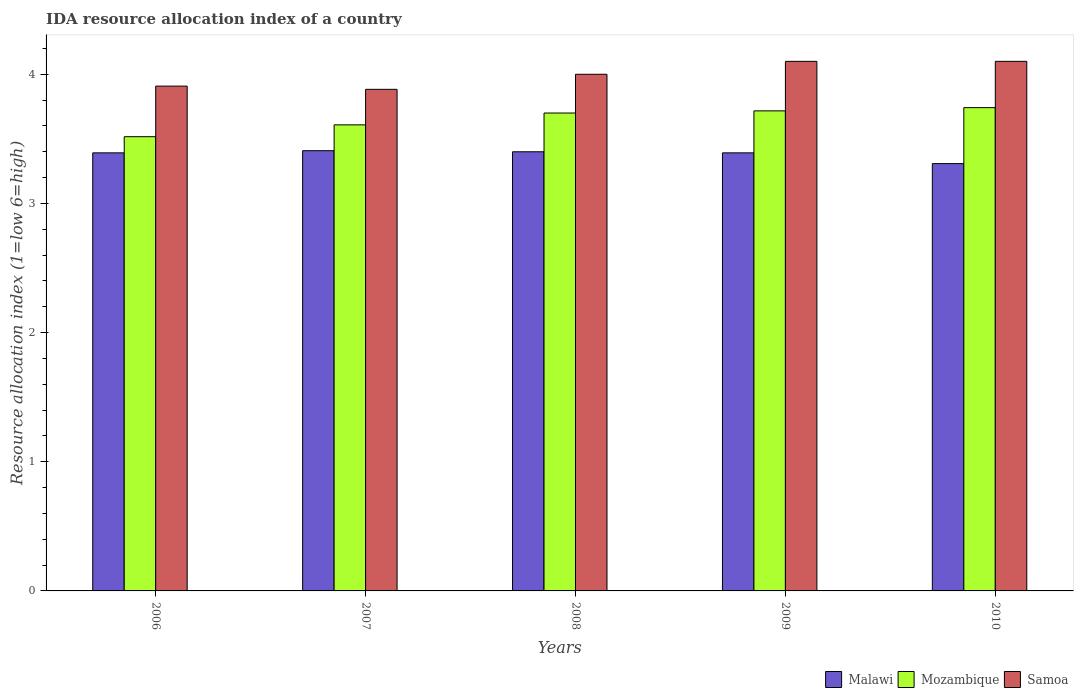How many different coloured bars are there?
Ensure brevity in your answer.  3. Are the number of bars per tick equal to the number of legend labels?
Provide a short and direct response. Yes. How many bars are there on the 1st tick from the right?
Ensure brevity in your answer.  3. In how many cases, is the number of bars for a given year not equal to the number of legend labels?
Offer a terse response. 0. What is the IDA resource allocation index in Samoa in 2006?
Offer a very short reply. 3.91. Across all years, what is the maximum IDA resource allocation index in Mozambique?
Offer a terse response. 3.74. Across all years, what is the minimum IDA resource allocation index in Samoa?
Your answer should be compact. 3.88. In which year was the IDA resource allocation index in Samoa maximum?
Your answer should be very brief. 2009. What is the total IDA resource allocation index in Malawi in the graph?
Provide a short and direct response. 16.9. What is the difference between the IDA resource allocation index in Malawi in 2008 and that in 2010?
Provide a succinct answer. 0.09. What is the difference between the IDA resource allocation index in Samoa in 2007 and the IDA resource allocation index in Mozambique in 2010?
Your response must be concise. 0.14. What is the average IDA resource allocation index in Samoa per year?
Your answer should be compact. 4. In the year 2009, what is the difference between the IDA resource allocation index in Malawi and IDA resource allocation index in Samoa?
Provide a succinct answer. -0.71. In how many years, is the IDA resource allocation index in Malawi greater than 3.8?
Your answer should be compact. 0. What is the ratio of the IDA resource allocation index in Mozambique in 2009 to that in 2010?
Provide a short and direct response. 0.99. Is the difference between the IDA resource allocation index in Malawi in 2007 and 2010 greater than the difference between the IDA resource allocation index in Samoa in 2007 and 2010?
Your answer should be compact. Yes. What is the difference between the highest and the second highest IDA resource allocation index in Malawi?
Your answer should be very brief. 0.01. What is the difference between the highest and the lowest IDA resource allocation index in Malawi?
Your answer should be very brief. 0.1. In how many years, is the IDA resource allocation index in Samoa greater than the average IDA resource allocation index in Samoa taken over all years?
Make the answer very short. 3. Is the sum of the IDA resource allocation index in Malawi in 2006 and 2007 greater than the maximum IDA resource allocation index in Mozambique across all years?
Make the answer very short. Yes. What does the 2nd bar from the left in 2006 represents?
Make the answer very short. Mozambique. What does the 2nd bar from the right in 2010 represents?
Ensure brevity in your answer.  Mozambique. Is it the case that in every year, the sum of the IDA resource allocation index in Samoa and IDA resource allocation index in Mozambique is greater than the IDA resource allocation index in Malawi?
Offer a very short reply. Yes. How many bars are there?
Keep it short and to the point. 15. Are all the bars in the graph horizontal?
Keep it short and to the point. No. What is the difference between two consecutive major ticks on the Y-axis?
Offer a very short reply. 1. What is the title of the graph?
Your response must be concise. IDA resource allocation index of a country. What is the label or title of the X-axis?
Provide a short and direct response. Years. What is the label or title of the Y-axis?
Your response must be concise. Resource allocation index (1=low 6=high). What is the Resource allocation index (1=low 6=high) of Malawi in 2006?
Keep it short and to the point. 3.39. What is the Resource allocation index (1=low 6=high) of Mozambique in 2006?
Offer a terse response. 3.52. What is the Resource allocation index (1=low 6=high) in Samoa in 2006?
Give a very brief answer. 3.91. What is the Resource allocation index (1=low 6=high) of Malawi in 2007?
Offer a terse response. 3.41. What is the Resource allocation index (1=low 6=high) of Mozambique in 2007?
Offer a very short reply. 3.61. What is the Resource allocation index (1=low 6=high) in Samoa in 2007?
Your answer should be very brief. 3.88. What is the Resource allocation index (1=low 6=high) in Samoa in 2008?
Provide a short and direct response. 4. What is the Resource allocation index (1=low 6=high) of Malawi in 2009?
Your answer should be compact. 3.39. What is the Resource allocation index (1=low 6=high) of Mozambique in 2009?
Your answer should be compact. 3.72. What is the Resource allocation index (1=low 6=high) of Malawi in 2010?
Provide a short and direct response. 3.31. What is the Resource allocation index (1=low 6=high) in Mozambique in 2010?
Provide a short and direct response. 3.74. What is the Resource allocation index (1=low 6=high) in Samoa in 2010?
Make the answer very short. 4.1. Across all years, what is the maximum Resource allocation index (1=low 6=high) in Malawi?
Give a very brief answer. 3.41. Across all years, what is the maximum Resource allocation index (1=low 6=high) in Mozambique?
Offer a very short reply. 3.74. Across all years, what is the maximum Resource allocation index (1=low 6=high) in Samoa?
Provide a succinct answer. 4.1. Across all years, what is the minimum Resource allocation index (1=low 6=high) of Malawi?
Your answer should be compact. 3.31. Across all years, what is the minimum Resource allocation index (1=low 6=high) in Mozambique?
Keep it short and to the point. 3.52. Across all years, what is the minimum Resource allocation index (1=low 6=high) in Samoa?
Offer a terse response. 3.88. What is the total Resource allocation index (1=low 6=high) of Malawi in the graph?
Provide a succinct answer. 16.9. What is the total Resource allocation index (1=low 6=high) in Mozambique in the graph?
Offer a terse response. 18.28. What is the total Resource allocation index (1=low 6=high) of Samoa in the graph?
Ensure brevity in your answer.  19.99. What is the difference between the Resource allocation index (1=low 6=high) of Malawi in 2006 and that in 2007?
Keep it short and to the point. -0.02. What is the difference between the Resource allocation index (1=low 6=high) in Mozambique in 2006 and that in 2007?
Provide a short and direct response. -0.09. What is the difference between the Resource allocation index (1=low 6=high) of Samoa in 2006 and that in 2007?
Make the answer very short. 0.03. What is the difference between the Resource allocation index (1=low 6=high) of Malawi in 2006 and that in 2008?
Your answer should be compact. -0.01. What is the difference between the Resource allocation index (1=low 6=high) of Mozambique in 2006 and that in 2008?
Ensure brevity in your answer.  -0.18. What is the difference between the Resource allocation index (1=low 6=high) of Samoa in 2006 and that in 2008?
Your answer should be very brief. -0.09. What is the difference between the Resource allocation index (1=low 6=high) of Samoa in 2006 and that in 2009?
Provide a succinct answer. -0.19. What is the difference between the Resource allocation index (1=low 6=high) in Malawi in 2006 and that in 2010?
Offer a very short reply. 0.08. What is the difference between the Resource allocation index (1=low 6=high) of Mozambique in 2006 and that in 2010?
Give a very brief answer. -0.23. What is the difference between the Resource allocation index (1=low 6=high) in Samoa in 2006 and that in 2010?
Provide a short and direct response. -0.19. What is the difference between the Resource allocation index (1=low 6=high) of Malawi in 2007 and that in 2008?
Your answer should be very brief. 0.01. What is the difference between the Resource allocation index (1=low 6=high) in Mozambique in 2007 and that in 2008?
Offer a very short reply. -0.09. What is the difference between the Resource allocation index (1=low 6=high) in Samoa in 2007 and that in 2008?
Offer a terse response. -0.12. What is the difference between the Resource allocation index (1=low 6=high) of Malawi in 2007 and that in 2009?
Give a very brief answer. 0.02. What is the difference between the Resource allocation index (1=low 6=high) in Mozambique in 2007 and that in 2009?
Make the answer very short. -0.11. What is the difference between the Resource allocation index (1=low 6=high) of Samoa in 2007 and that in 2009?
Your response must be concise. -0.22. What is the difference between the Resource allocation index (1=low 6=high) in Mozambique in 2007 and that in 2010?
Your answer should be very brief. -0.13. What is the difference between the Resource allocation index (1=low 6=high) in Samoa in 2007 and that in 2010?
Your response must be concise. -0.22. What is the difference between the Resource allocation index (1=low 6=high) in Malawi in 2008 and that in 2009?
Your response must be concise. 0.01. What is the difference between the Resource allocation index (1=low 6=high) of Mozambique in 2008 and that in 2009?
Your response must be concise. -0.02. What is the difference between the Resource allocation index (1=low 6=high) of Malawi in 2008 and that in 2010?
Give a very brief answer. 0.09. What is the difference between the Resource allocation index (1=low 6=high) of Mozambique in 2008 and that in 2010?
Your answer should be very brief. -0.04. What is the difference between the Resource allocation index (1=low 6=high) in Samoa in 2008 and that in 2010?
Make the answer very short. -0.1. What is the difference between the Resource allocation index (1=low 6=high) in Malawi in 2009 and that in 2010?
Give a very brief answer. 0.08. What is the difference between the Resource allocation index (1=low 6=high) of Mozambique in 2009 and that in 2010?
Your response must be concise. -0.03. What is the difference between the Resource allocation index (1=low 6=high) of Malawi in 2006 and the Resource allocation index (1=low 6=high) of Mozambique in 2007?
Your answer should be compact. -0.22. What is the difference between the Resource allocation index (1=low 6=high) in Malawi in 2006 and the Resource allocation index (1=low 6=high) in Samoa in 2007?
Your response must be concise. -0.49. What is the difference between the Resource allocation index (1=low 6=high) in Mozambique in 2006 and the Resource allocation index (1=low 6=high) in Samoa in 2007?
Your response must be concise. -0.37. What is the difference between the Resource allocation index (1=low 6=high) of Malawi in 2006 and the Resource allocation index (1=low 6=high) of Mozambique in 2008?
Provide a succinct answer. -0.31. What is the difference between the Resource allocation index (1=low 6=high) of Malawi in 2006 and the Resource allocation index (1=low 6=high) of Samoa in 2008?
Your response must be concise. -0.61. What is the difference between the Resource allocation index (1=low 6=high) in Mozambique in 2006 and the Resource allocation index (1=low 6=high) in Samoa in 2008?
Your response must be concise. -0.48. What is the difference between the Resource allocation index (1=low 6=high) of Malawi in 2006 and the Resource allocation index (1=low 6=high) of Mozambique in 2009?
Your answer should be very brief. -0.33. What is the difference between the Resource allocation index (1=low 6=high) of Malawi in 2006 and the Resource allocation index (1=low 6=high) of Samoa in 2009?
Keep it short and to the point. -0.71. What is the difference between the Resource allocation index (1=low 6=high) of Mozambique in 2006 and the Resource allocation index (1=low 6=high) of Samoa in 2009?
Keep it short and to the point. -0.58. What is the difference between the Resource allocation index (1=low 6=high) of Malawi in 2006 and the Resource allocation index (1=low 6=high) of Mozambique in 2010?
Provide a short and direct response. -0.35. What is the difference between the Resource allocation index (1=low 6=high) of Malawi in 2006 and the Resource allocation index (1=low 6=high) of Samoa in 2010?
Provide a short and direct response. -0.71. What is the difference between the Resource allocation index (1=low 6=high) in Mozambique in 2006 and the Resource allocation index (1=low 6=high) in Samoa in 2010?
Give a very brief answer. -0.58. What is the difference between the Resource allocation index (1=low 6=high) in Malawi in 2007 and the Resource allocation index (1=low 6=high) in Mozambique in 2008?
Your answer should be very brief. -0.29. What is the difference between the Resource allocation index (1=low 6=high) in Malawi in 2007 and the Resource allocation index (1=low 6=high) in Samoa in 2008?
Give a very brief answer. -0.59. What is the difference between the Resource allocation index (1=low 6=high) in Mozambique in 2007 and the Resource allocation index (1=low 6=high) in Samoa in 2008?
Your answer should be compact. -0.39. What is the difference between the Resource allocation index (1=low 6=high) of Malawi in 2007 and the Resource allocation index (1=low 6=high) of Mozambique in 2009?
Your answer should be very brief. -0.31. What is the difference between the Resource allocation index (1=low 6=high) in Malawi in 2007 and the Resource allocation index (1=low 6=high) in Samoa in 2009?
Your answer should be very brief. -0.69. What is the difference between the Resource allocation index (1=low 6=high) in Mozambique in 2007 and the Resource allocation index (1=low 6=high) in Samoa in 2009?
Provide a short and direct response. -0.49. What is the difference between the Resource allocation index (1=low 6=high) in Malawi in 2007 and the Resource allocation index (1=low 6=high) in Mozambique in 2010?
Your response must be concise. -0.33. What is the difference between the Resource allocation index (1=low 6=high) in Malawi in 2007 and the Resource allocation index (1=low 6=high) in Samoa in 2010?
Ensure brevity in your answer.  -0.69. What is the difference between the Resource allocation index (1=low 6=high) in Mozambique in 2007 and the Resource allocation index (1=low 6=high) in Samoa in 2010?
Ensure brevity in your answer.  -0.49. What is the difference between the Resource allocation index (1=low 6=high) in Malawi in 2008 and the Resource allocation index (1=low 6=high) in Mozambique in 2009?
Ensure brevity in your answer.  -0.32. What is the difference between the Resource allocation index (1=low 6=high) of Malawi in 2008 and the Resource allocation index (1=low 6=high) of Samoa in 2009?
Your answer should be very brief. -0.7. What is the difference between the Resource allocation index (1=low 6=high) of Mozambique in 2008 and the Resource allocation index (1=low 6=high) of Samoa in 2009?
Offer a terse response. -0.4. What is the difference between the Resource allocation index (1=low 6=high) of Malawi in 2008 and the Resource allocation index (1=low 6=high) of Mozambique in 2010?
Keep it short and to the point. -0.34. What is the difference between the Resource allocation index (1=low 6=high) in Mozambique in 2008 and the Resource allocation index (1=low 6=high) in Samoa in 2010?
Provide a succinct answer. -0.4. What is the difference between the Resource allocation index (1=low 6=high) of Malawi in 2009 and the Resource allocation index (1=low 6=high) of Mozambique in 2010?
Your response must be concise. -0.35. What is the difference between the Resource allocation index (1=low 6=high) of Malawi in 2009 and the Resource allocation index (1=low 6=high) of Samoa in 2010?
Offer a very short reply. -0.71. What is the difference between the Resource allocation index (1=low 6=high) of Mozambique in 2009 and the Resource allocation index (1=low 6=high) of Samoa in 2010?
Ensure brevity in your answer.  -0.38. What is the average Resource allocation index (1=low 6=high) in Malawi per year?
Ensure brevity in your answer.  3.38. What is the average Resource allocation index (1=low 6=high) of Mozambique per year?
Your response must be concise. 3.66. What is the average Resource allocation index (1=low 6=high) in Samoa per year?
Keep it short and to the point. 4. In the year 2006, what is the difference between the Resource allocation index (1=low 6=high) of Malawi and Resource allocation index (1=low 6=high) of Mozambique?
Your answer should be very brief. -0.12. In the year 2006, what is the difference between the Resource allocation index (1=low 6=high) of Malawi and Resource allocation index (1=low 6=high) of Samoa?
Your answer should be compact. -0.52. In the year 2006, what is the difference between the Resource allocation index (1=low 6=high) in Mozambique and Resource allocation index (1=low 6=high) in Samoa?
Provide a succinct answer. -0.39. In the year 2007, what is the difference between the Resource allocation index (1=low 6=high) of Malawi and Resource allocation index (1=low 6=high) of Mozambique?
Offer a terse response. -0.2. In the year 2007, what is the difference between the Resource allocation index (1=low 6=high) in Malawi and Resource allocation index (1=low 6=high) in Samoa?
Your answer should be compact. -0.47. In the year 2007, what is the difference between the Resource allocation index (1=low 6=high) in Mozambique and Resource allocation index (1=low 6=high) in Samoa?
Make the answer very short. -0.28. In the year 2008, what is the difference between the Resource allocation index (1=low 6=high) in Mozambique and Resource allocation index (1=low 6=high) in Samoa?
Your answer should be compact. -0.3. In the year 2009, what is the difference between the Resource allocation index (1=low 6=high) of Malawi and Resource allocation index (1=low 6=high) of Mozambique?
Offer a very short reply. -0.33. In the year 2009, what is the difference between the Resource allocation index (1=low 6=high) of Malawi and Resource allocation index (1=low 6=high) of Samoa?
Provide a succinct answer. -0.71. In the year 2009, what is the difference between the Resource allocation index (1=low 6=high) of Mozambique and Resource allocation index (1=low 6=high) of Samoa?
Offer a very short reply. -0.38. In the year 2010, what is the difference between the Resource allocation index (1=low 6=high) in Malawi and Resource allocation index (1=low 6=high) in Mozambique?
Give a very brief answer. -0.43. In the year 2010, what is the difference between the Resource allocation index (1=low 6=high) of Malawi and Resource allocation index (1=low 6=high) of Samoa?
Give a very brief answer. -0.79. In the year 2010, what is the difference between the Resource allocation index (1=low 6=high) in Mozambique and Resource allocation index (1=low 6=high) in Samoa?
Offer a terse response. -0.36. What is the ratio of the Resource allocation index (1=low 6=high) in Mozambique in 2006 to that in 2007?
Make the answer very short. 0.97. What is the ratio of the Resource allocation index (1=low 6=high) in Samoa in 2006 to that in 2007?
Provide a short and direct response. 1.01. What is the ratio of the Resource allocation index (1=low 6=high) in Malawi in 2006 to that in 2008?
Give a very brief answer. 1. What is the ratio of the Resource allocation index (1=low 6=high) of Mozambique in 2006 to that in 2008?
Provide a short and direct response. 0.95. What is the ratio of the Resource allocation index (1=low 6=high) in Samoa in 2006 to that in 2008?
Offer a very short reply. 0.98. What is the ratio of the Resource allocation index (1=low 6=high) in Mozambique in 2006 to that in 2009?
Provide a short and direct response. 0.95. What is the ratio of the Resource allocation index (1=low 6=high) in Samoa in 2006 to that in 2009?
Keep it short and to the point. 0.95. What is the ratio of the Resource allocation index (1=low 6=high) in Malawi in 2006 to that in 2010?
Provide a short and direct response. 1.03. What is the ratio of the Resource allocation index (1=low 6=high) of Mozambique in 2006 to that in 2010?
Provide a short and direct response. 0.94. What is the ratio of the Resource allocation index (1=low 6=high) of Samoa in 2006 to that in 2010?
Make the answer very short. 0.95. What is the ratio of the Resource allocation index (1=low 6=high) in Mozambique in 2007 to that in 2008?
Provide a succinct answer. 0.98. What is the ratio of the Resource allocation index (1=low 6=high) in Samoa in 2007 to that in 2008?
Provide a short and direct response. 0.97. What is the ratio of the Resource allocation index (1=low 6=high) in Malawi in 2007 to that in 2009?
Give a very brief answer. 1. What is the ratio of the Resource allocation index (1=low 6=high) in Mozambique in 2007 to that in 2009?
Keep it short and to the point. 0.97. What is the ratio of the Resource allocation index (1=low 6=high) in Samoa in 2007 to that in 2009?
Ensure brevity in your answer.  0.95. What is the ratio of the Resource allocation index (1=low 6=high) in Malawi in 2007 to that in 2010?
Keep it short and to the point. 1.03. What is the ratio of the Resource allocation index (1=low 6=high) of Mozambique in 2007 to that in 2010?
Give a very brief answer. 0.96. What is the ratio of the Resource allocation index (1=low 6=high) in Samoa in 2007 to that in 2010?
Provide a succinct answer. 0.95. What is the ratio of the Resource allocation index (1=low 6=high) of Malawi in 2008 to that in 2009?
Provide a succinct answer. 1. What is the ratio of the Resource allocation index (1=low 6=high) of Samoa in 2008 to that in 2009?
Your answer should be very brief. 0.98. What is the ratio of the Resource allocation index (1=low 6=high) in Malawi in 2008 to that in 2010?
Your answer should be compact. 1.03. What is the ratio of the Resource allocation index (1=low 6=high) of Mozambique in 2008 to that in 2010?
Provide a short and direct response. 0.99. What is the ratio of the Resource allocation index (1=low 6=high) of Samoa in 2008 to that in 2010?
Provide a short and direct response. 0.98. What is the ratio of the Resource allocation index (1=low 6=high) of Malawi in 2009 to that in 2010?
Make the answer very short. 1.03. What is the ratio of the Resource allocation index (1=low 6=high) of Mozambique in 2009 to that in 2010?
Provide a succinct answer. 0.99. What is the difference between the highest and the second highest Resource allocation index (1=low 6=high) of Malawi?
Make the answer very short. 0.01. What is the difference between the highest and the second highest Resource allocation index (1=low 6=high) of Mozambique?
Keep it short and to the point. 0.03. What is the difference between the highest and the second highest Resource allocation index (1=low 6=high) of Samoa?
Offer a very short reply. 0. What is the difference between the highest and the lowest Resource allocation index (1=low 6=high) in Mozambique?
Ensure brevity in your answer.  0.23. What is the difference between the highest and the lowest Resource allocation index (1=low 6=high) in Samoa?
Give a very brief answer. 0.22. 